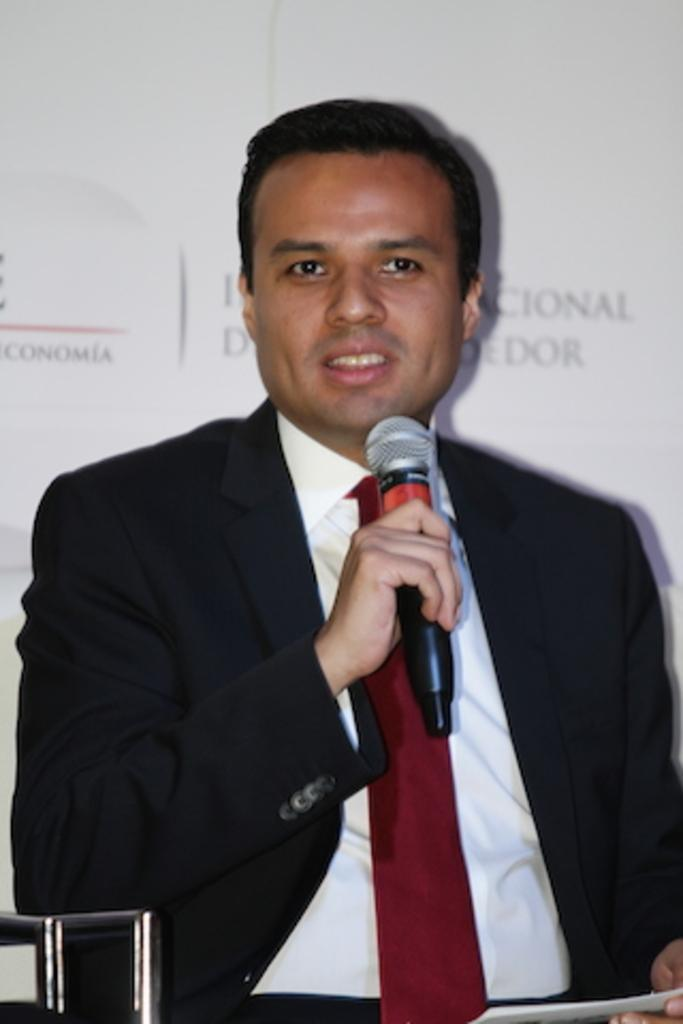Who is the main subject in the picture? There is a woman in the picture. What is the woman doing in the image? The woman is standing and smiling. What is the woman holding in her hands? The woman is holding a camera in her hands. What is the background of the image? The picture was taken in front of a mountain. What type of weather is depicted in the image? There is snow in the image. How many kittens can be seen playing in the snow in the image? There are no kittens present in the image; it features a woman standing in front of a mountain with snow. 